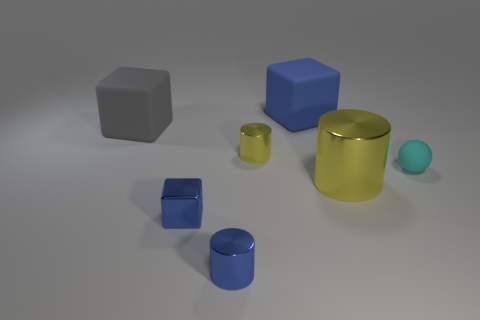There is another small object that is the same shape as the gray object; what material is it?
Make the answer very short. Metal. How many other blue objects have the same shape as the blue matte thing?
Your response must be concise. 1. There is a big yellow object; does it have the same shape as the yellow object left of the big blue rubber thing?
Your answer should be compact. Yes. What shape is the metallic object that is the same color as the small block?
Provide a succinct answer. Cylinder. Are there fewer small things behind the big yellow thing than tiny blue cubes?
Make the answer very short. No. Does the big yellow metallic thing have the same shape as the tiny yellow thing?
Offer a terse response. Yes. There is another blue cylinder that is made of the same material as the large cylinder; what size is it?
Your answer should be compact. Small. Is the number of small objects less than the number of blue matte spheres?
Your response must be concise. No. What number of big objects are either blue things or red matte blocks?
Offer a terse response. 1. What number of objects are both in front of the big gray thing and on the right side of the small blue metallic block?
Your response must be concise. 4. 